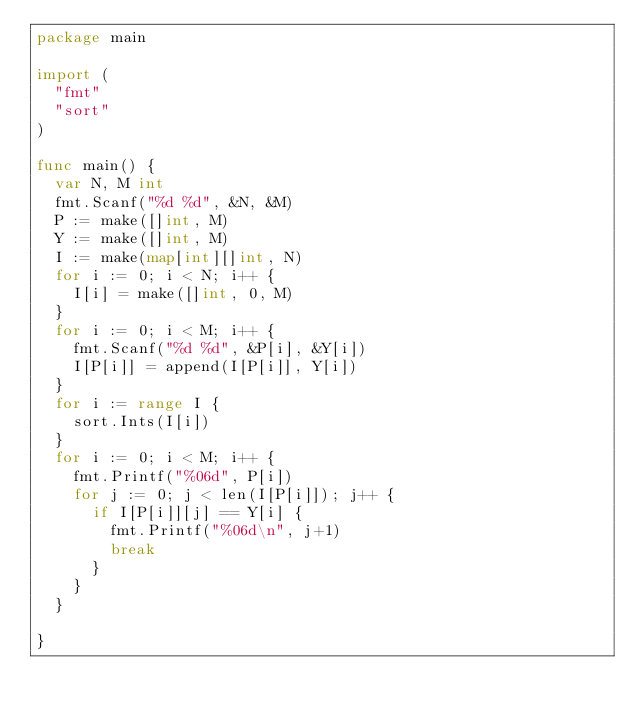Convert code to text. <code><loc_0><loc_0><loc_500><loc_500><_Go_>package main

import (
	"fmt"
	"sort"
)

func main() {
	var N, M int
	fmt.Scanf("%d %d", &N, &M)
	P := make([]int, M)
	Y := make([]int, M)
	I := make(map[int][]int, N)
	for i := 0; i < N; i++ {
		I[i] = make([]int, 0, M)
	}
	for i := 0; i < M; i++ {
		fmt.Scanf("%d %d", &P[i], &Y[i])
		I[P[i]] = append(I[P[i]], Y[i])
	}
	for i := range I {
		sort.Ints(I[i])
	}
	for i := 0; i < M; i++ {
		fmt.Printf("%06d", P[i])
		for j := 0; j < len(I[P[i]]); j++ {
			if I[P[i]][j] == Y[i] {
				fmt.Printf("%06d\n", j+1)
				break
			}
		}
	}

}</code> 